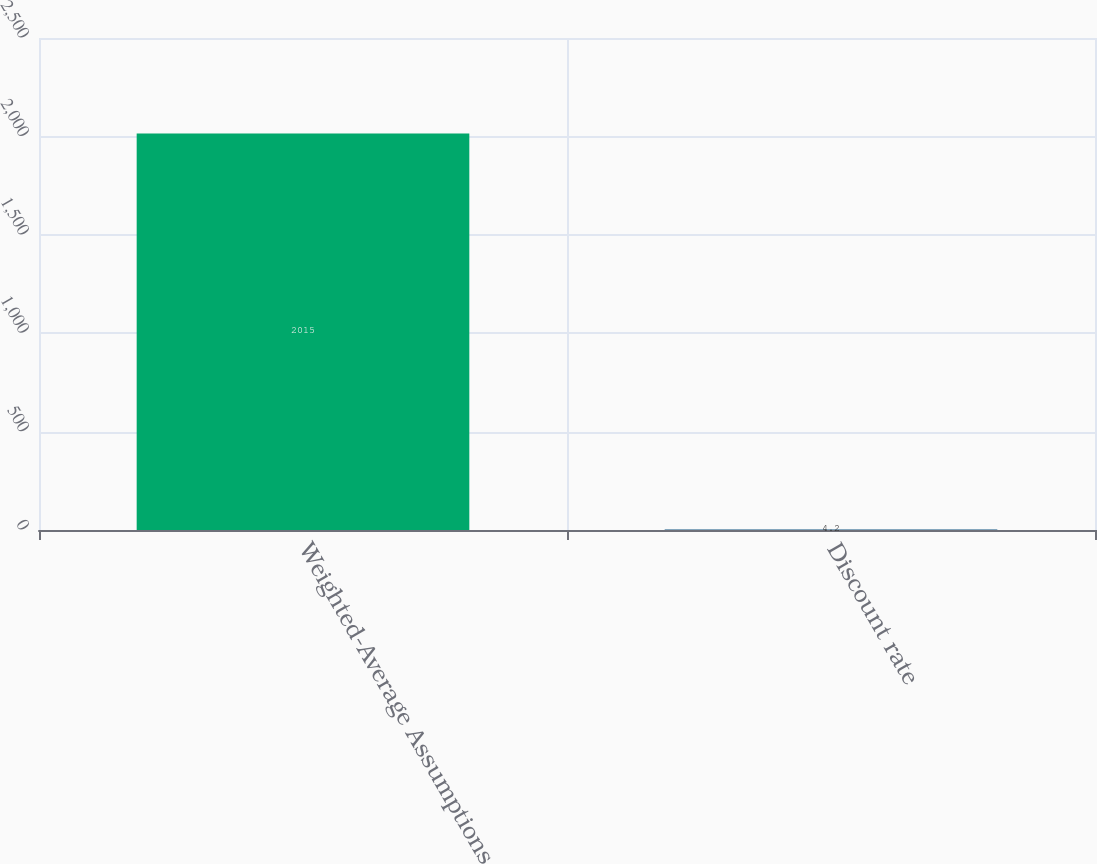Convert chart. <chart><loc_0><loc_0><loc_500><loc_500><bar_chart><fcel>Weighted-Average Assumptions<fcel>Discount rate<nl><fcel>2015<fcel>4.2<nl></chart> 